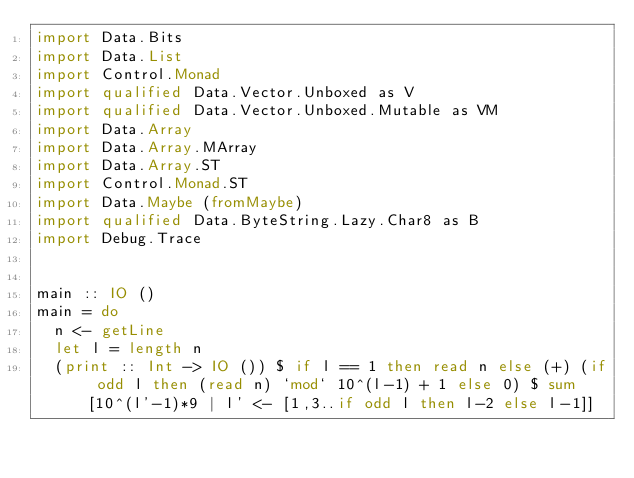Convert code to text. <code><loc_0><loc_0><loc_500><loc_500><_Haskell_>import Data.Bits
import Data.List
import Control.Monad
import qualified Data.Vector.Unboxed as V
import qualified Data.Vector.Unboxed.Mutable as VM
import Data.Array
import Data.Array.MArray
import Data.Array.ST
import Control.Monad.ST
import Data.Maybe (fromMaybe)
import qualified Data.ByteString.Lazy.Char8 as B
import Debug.Trace


main :: IO ()
main = do
  n <- getLine
  let l = length n
  (print :: Int -> IO ()) $ if l == 1 then read n else (+) (if odd l then (read n) `mod` 10^(l-1) + 1 else 0) $ sum [10^(l'-1)*9 | l' <- [1,3..if odd l then l-2 else l-1]]
</code> 